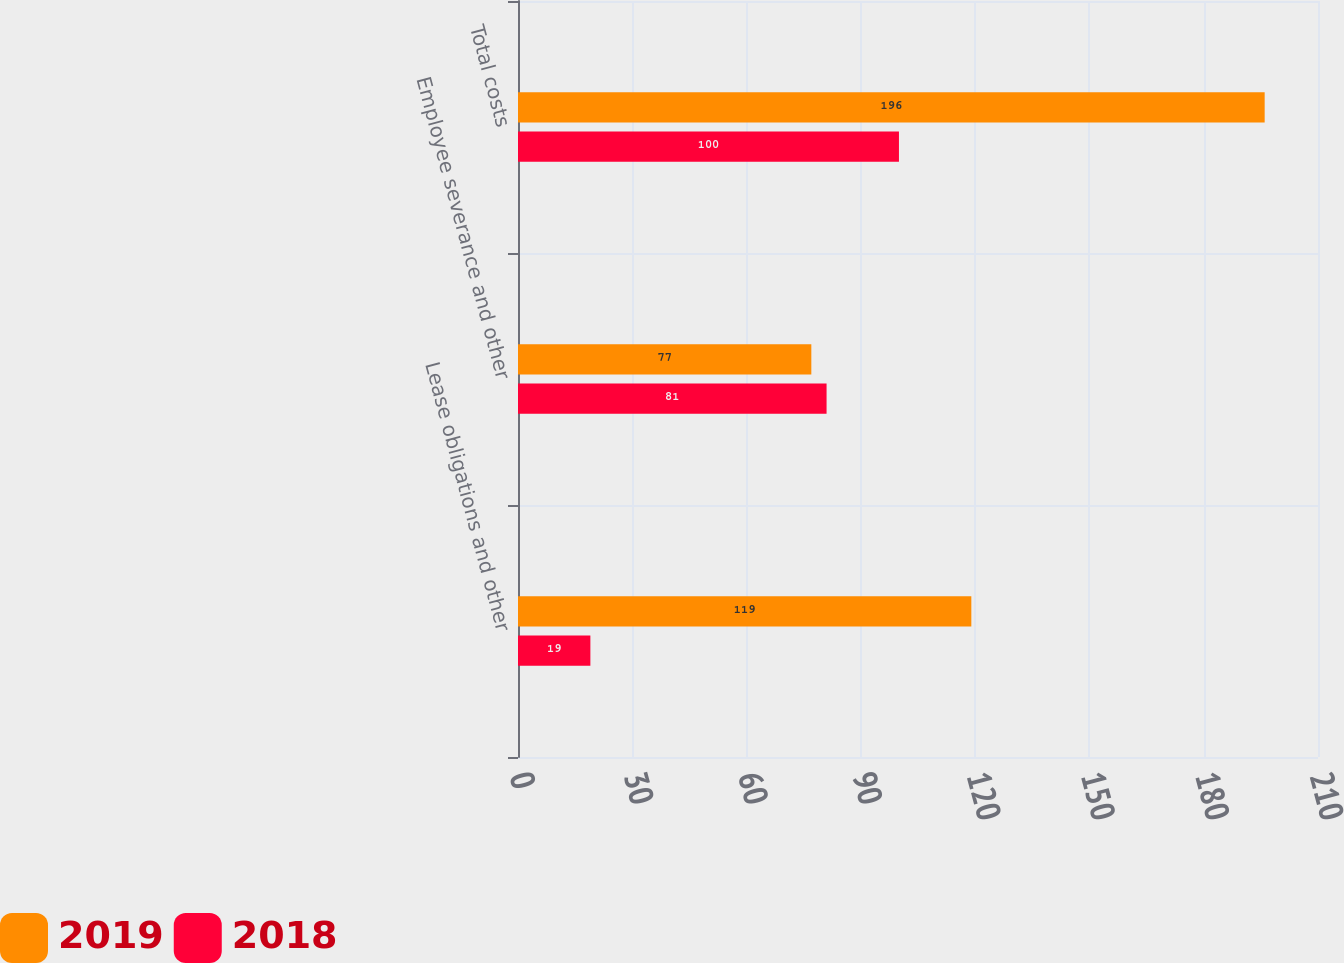Convert chart to OTSL. <chart><loc_0><loc_0><loc_500><loc_500><stacked_bar_chart><ecel><fcel>Lease obligations and other<fcel>Employee severance and other<fcel>Total costs<nl><fcel>2019<fcel>119<fcel>77<fcel>196<nl><fcel>2018<fcel>19<fcel>81<fcel>100<nl></chart> 